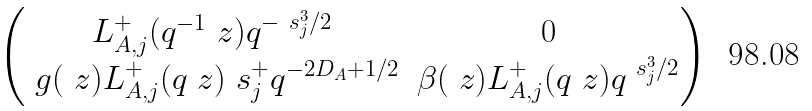<formula> <loc_0><loc_0><loc_500><loc_500>\begin{pmatrix} L ^ { + } _ { A , j } ( q ^ { - 1 } \ z ) q ^ { - \ s ^ { 3 } _ { j } / 2 } & 0 \\ \ g ( \ z ) L ^ { + } _ { A , j } ( q \ z ) \ s ^ { + } _ { j } q ^ { - 2 D _ { A } + 1 / 2 } & \beta ( \ z ) L ^ { + } _ { A , j } ( q \ z ) q ^ { \ s ^ { 3 } _ { j } / 2 } \end{pmatrix}</formula> 